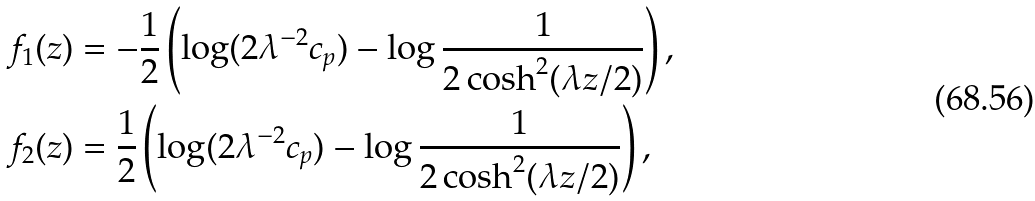<formula> <loc_0><loc_0><loc_500><loc_500>f _ { 1 } ( z ) & = - \frac { 1 } { 2 } \left ( \log ( 2 \lambda ^ { - 2 } c _ { p } ) - \log \frac { 1 } { 2 \cosh ^ { 2 } ( \lambda z / 2 ) } \right ) , \\ f _ { 2 } ( z ) & = \frac { 1 } { 2 } \left ( \log ( 2 \lambda ^ { - 2 } c _ { p } ) - \log \frac { 1 } { 2 \cosh ^ { 2 } ( \lambda z / 2 ) } \right ) ,</formula> 